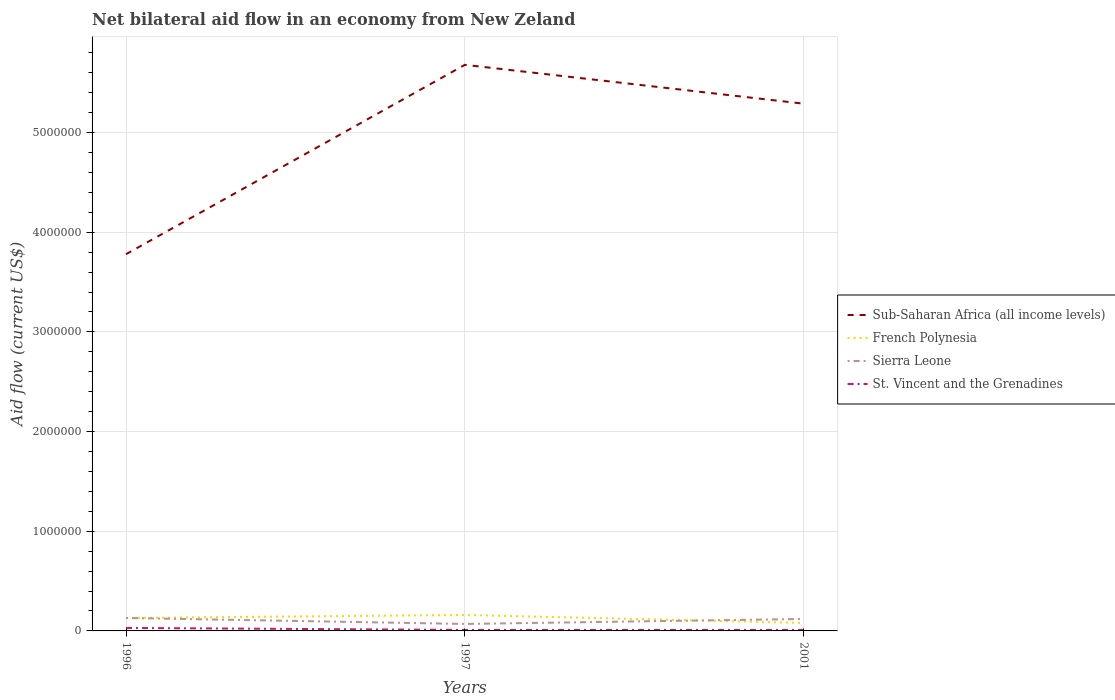How many different coloured lines are there?
Your answer should be very brief. 4. Is the number of lines equal to the number of legend labels?
Make the answer very short. Yes. In which year was the net bilateral aid flow in Sierra Leone maximum?
Your answer should be very brief. 1997. What is the total net bilateral aid flow in Sub-Saharan Africa (all income levels) in the graph?
Keep it short and to the point. 3.90e+05. What is the difference between the highest and the lowest net bilateral aid flow in Sub-Saharan Africa (all income levels)?
Offer a terse response. 2. Is the net bilateral aid flow in French Polynesia strictly greater than the net bilateral aid flow in Sub-Saharan Africa (all income levels) over the years?
Make the answer very short. Yes. How many years are there in the graph?
Provide a short and direct response. 3. What is the difference between two consecutive major ticks on the Y-axis?
Your response must be concise. 1.00e+06. Are the values on the major ticks of Y-axis written in scientific E-notation?
Provide a succinct answer. No. Where does the legend appear in the graph?
Provide a succinct answer. Center right. How are the legend labels stacked?
Ensure brevity in your answer.  Vertical. What is the title of the graph?
Provide a succinct answer. Net bilateral aid flow in an economy from New Zeland. What is the label or title of the X-axis?
Keep it short and to the point. Years. What is the label or title of the Y-axis?
Offer a very short reply. Aid flow (current US$). What is the Aid flow (current US$) in Sub-Saharan Africa (all income levels) in 1996?
Give a very brief answer. 3.78e+06. What is the Aid flow (current US$) of French Polynesia in 1996?
Your answer should be compact. 1.30e+05. What is the Aid flow (current US$) of Sierra Leone in 1996?
Provide a succinct answer. 1.30e+05. What is the Aid flow (current US$) in St. Vincent and the Grenadines in 1996?
Make the answer very short. 3.00e+04. What is the Aid flow (current US$) of Sub-Saharan Africa (all income levels) in 1997?
Provide a succinct answer. 5.68e+06. What is the Aid flow (current US$) of French Polynesia in 1997?
Provide a succinct answer. 1.60e+05. What is the Aid flow (current US$) of St. Vincent and the Grenadines in 1997?
Your answer should be very brief. 10000. What is the Aid flow (current US$) of Sub-Saharan Africa (all income levels) in 2001?
Your answer should be compact. 5.29e+06. What is the Aid flow (current US$) in Sierra Leone in 2001?
Your answer should be very brief. 1.20e+05. Across all years, what is the maximum Aid flow (current US$) of Sub-Saharan Africa (all income levels)?
Your answer should be very brief. 5.68e+06. Across all years, what is the maximum Aid flow (current US$) in Sierra Leone?
Make the answer very short. 1.30e+05. Across all years, what is the minimum Aid flow (current US$) of Sub-Saharan Africa (all income levels)?
Offer a very short reply. 3.78e+06. Across all years, what is the minimum Aid flow (current US$) of Sierra Leone?
Offer a terse response. 7.00e+04. What is the total Aid flow (current US$) of Sub-Saharan Africa (all income levels) in the graph?
Make the answer very short. 1.48e+07. What is the total Aid flow (current US$) in Sierra Leone in the graph?
Provide a short and direct response. 3.20e+05. What is the total Aid flow (current US$) in St. Vincent and the Grenadines in the graph?
Keep it short and to the point. 5.00e+04. What is the difference between the Aid flow (current US$) of Sub-Saharan Africa (all income levels) in 1996 and that in 1997?
Provide a short and direct response. -1.90e+06. What is the difference between the Aid flow (current US$) of French Polynesia in 1996 and that in 1997?
Keep it short and to the point. -3.00e+04. What is the difference between the Aid flow (current US$) of St. Vincent and the Grenadines in 1996 and that in 1997?
Your answer should be compact. 2.00e+04. What is the difference between the Aid flow (current US$) of Sub-Saharan Africa (all income levels) in 1996 and that in 2001?
Your response must be concise. -1.51e+06. What is the difference between the Aid flow (current US$) in Sierra Leone in 1996 and that in 2001?
Provide a succinct answer. 10000. What is the difference between the Aid flow (current US$) in Sierra Leone in 1997 and that in 2001?
Keep it short and to the point. -5.00e+04. What is the difference between the Aid flow (current US$) of St. Vincent and the Grenadines in 1997 and that in 2001?
Provide a succinct answer. 0. What is the difference between the Aid flow (current US$) in Sub-Saharan Africa (all income levels) in 1996 and the Aid flow (current US$) in French Polynesia in 1997?
Give a very brief answer. 3.62e+06. What is the difference between the Aid flow (current US$) in Sub-Saharan Africa (all income levels) in 1996 and the Aid flow (current US$) in Sierra Leone in 1997?
Ensure brevity in your answer.  3.71e+06. What is the difference between the Aid flow (current US$) in Sub-Saharan Africa (all income levels) in 1996 and the Aid flow (current US$) in St. Vincent and the Grenadines in 1997?
Your answer should be very brief. 3.77e+06. What is the difference between the Aid flow (current US$) in French Polynesia in 1996 and the Aid flow (current US$) in Sierra Leone in 1997?
Your answer should be very brief. 6.00e+04. What is the difference between the Aid flow (current US$) of Sub-Saharan Africa (all income levels) in 1996 and the Aid flow (current US$) of French Polynesia in 2001?
Provide a short and direct response. 3.70e+06. What is the difference between the Aid flow (current US$) of Sub-Saharan Africa (all income levels) in 1996 and the Aid flow (current US$) of Sierra Leone in 2001?
Keep it short and to the point. 3.66e+06. What is the difference between the Aid flow (current US$) of Sub-Saharan Africa (all income levels) in 1996 and the Aid flow (current US$) of St. Vincent and the Grenadines in 2001?
Your answer should be compact. 3.77e+06. What is the difference between the Aid flow (current US$) of French Polynesia in 1996 and the Aid flow (current US$) of Sierra Leone in 2001?
Give a very brief answer. 10000. What is the difference between the Aid flow (current US$) in French Polynesia in 1996 and the Aid flow (current US$) in St. Vincent and the Grenadines in 2001?
Provide a succinct answer. 1.20e+05. What is the difference between the Aid flow (current US$) in Sub-Saharan Africa (all income levels) in 1997 and the Aid flow (current US$) in French Polynesia in 2001?
Give a very brief answer. 5.60e+06. What is the difference between the Aid flow (current US$) in Sub-Saharan Africa (all income levels) in 1997 and the Aid flow (current US$) in Sierra Leone in 2001?
Your response must be concise. 5.56e+06. What is the difference between the Aid flow (current US$) of Sub-Saharan Africa (all income levels) in 1997 and the Aid flow (current US$) of St. Vincent and the Grenadines in 2001?
Your answer should be compact. 5.67e+06. What is the difference between the Aid flow (current US$) of French Polynesia in 1997 and the Aid flow (current US$) of St. Vincent and the Grenadines in 2001?
Offer a very short reply. 1.50e+05. What is the difference between the Aid flow (current US$) of Sierra Leone in 1997 and the Aid flow (current US$) of St. Vincent and the Grenadines in 2001?
Your answer should be very brief. 6.00e+04. What is the average Aid flow (current US$) of Sub-Saharan Africa (all income levels) per year?
Give a very brief answer. 4.92e+06. What is the average Aid flow (current US$) of French Polynesia per year?
Offer a terse response. 1.23e+05. What is the average Aid flow (current US$) in Sierra Leone per year?
Ensure brevity in your answer.  1.07e+05. What is the average Aid flow (current US$) in St. Vincent and the Grenadines per year?
Provide a succinct answer. 1.67e+04. In the year 1996, what is the difference between the Aid flow (current US$) in Sub-Saharan Africa (all income levels) and Aid flow (current US$) in French Polynesia?
Your answer should be very brief. 3.65e+06. In the year 1996, what is the difference between the Aid flow (current US$) in Sub-Saharan Africa (all income levels) and Aid flow (current US$) in Sierra Leone?
Offer a terse response. 3.65e+06. In the year 1996, what is the difference between the Aid flow (current US$) in Sub-Saharan Africa (all income levels) and Aid flow (current US$) in St. Vincent and the Grenadines?
Give a very brief answer. 3.75e+06. In the year 1996, what is the difference between the Aid flow (current US$) of French Polynesia and Aid flow (current US$) of Sierra Leone?
Offer a very short reply. 0. In the year 1996, what is the difference between the Aid flow (current US$) in French Polynesia and Aid flow (current US$) in St. Vincent and the Grenadines?
Ensure brevity in your answer.  1.00e+05. In the year 1997, what is the difference between the Aid flow (current US$) of Sub-Saharan Africa (all income levels) and Aid flow (current US$) of French Polynesia?
Give a very brief answer. 5.52e+06. In the year 1997, what is the difference between the Aid flow (current US$) of Sub-Saharan Africa (all income levels) and Aid flow (current US$) of Sierra Leone?
Offer a very short reply. 5.61e+06. In the year 1997, what is the difference between the Aid flow (current US$) of Sub-Saharan Africa (all income levels) and Aid flow (current US$) of St. Vincent and the Grenadines?
Offer a very short reply. 5.67e+06. In the year 1997, what is the difference between the Aid flow (current US$) in French Polynesia and Aid flow (current US$) in Sierra Leone?
Give a very brief answer. 9.00e+04. In the year 2001, what is the difference between the Aid flow (current US$) of Sub-Saharan Africa (all income levels) and Aid flow (current US$) of French Polynesia?
Your answer should be compact. 5.21e+06. In the year 2001, what is the difference between the Aid flow (current US$) of Sub-Saharan Africa (all income levels) and Aid flow (current US$) of Sierra Leone?
Give a very brief answer. 5.17e+06. In the year 2001, what is the difference between the Aid flow (current US$) in Sub-Saharan Africa (all income levels) and Aid flow (current US$) in St. Vincent and the Grenadines?
Your response must be concise. 5.28e+06. In the year 2001, what is the difference between the Aid flow (current US$) of French Polynesia and Aid flow (current US$) of St. Vincent and the Grenadines?
Your answer should be compact. 7.00e+04. In the year 2001, what is the difference between the Aid flow (current US$) in Sierra Leone and Aid flow (current US$) in St. Vincent and the Grenadines?
Provide a short and direct response. 1.10e+05. What is the ratio of the Aid flow (current US$) in Sub-Saharan Africa (all income levels) in 1996 to that in 1997?
Your answer should be very brief. 0.67. What is the ratio of the Aid flow (current US$) in French Polynesia in 1996 to that in 1997?
Your response must be concise. 0.81. What is the ratio of the Aid flow (current US$) of Sierra Leone in 1996 to that in 1997?
Ensure brevity in your answer.  1.86. What is the ratio of the Aid flow (current US$) of Sub-Saharan Africa (all income levels) in 1996 to that in 2001?
Keep it short and to the point. 0.71. What is the ratio of the Aid flow (current US$) of French Polynesia in 1996 to that in 2001?
Offer a very short reply. 1.62. What is the ratio of the Aid flow (current US$) in Sub-Saharan Africa (all income levels) in 1997 to that in 2001?
Your answer should be very brief. 1.07. What is the ratio of the Aid flow (current US$) in French Polynesia in 1997 to that in 2001?
Ensure brevity in your answer.  2. What is the ratio of the Aid flow (current US$) of Sierra Leone in 1997 to that in 2001?
Offer a very short reply. 0.58. What is the difference between the highest and the second highest Aid flow (current US$) of Sierra Leone?
Your response must be concise. 10000. What is the difference between the highest and the second highest Aid flow (current US$) in St. Vincent and the Grenadines?
Your answer should be very brief. 2.00e+04. What is the difference between the highest and the lowest Aid flow (current US$) in Sub-Saharan Africa (all income levels)?
Ensure brevity in your answer.  1.90e+06. What is the difference between the highest and the lowest Aid flow (current US$) in Sierra Leone?
Give a very brief answer. 6.00e+04. What is the difference between the highest and the lowest Aid flow (current US$) in St. Vincent and the Grenadines?
Ensure brevity in your answer.  2.00e+04. 